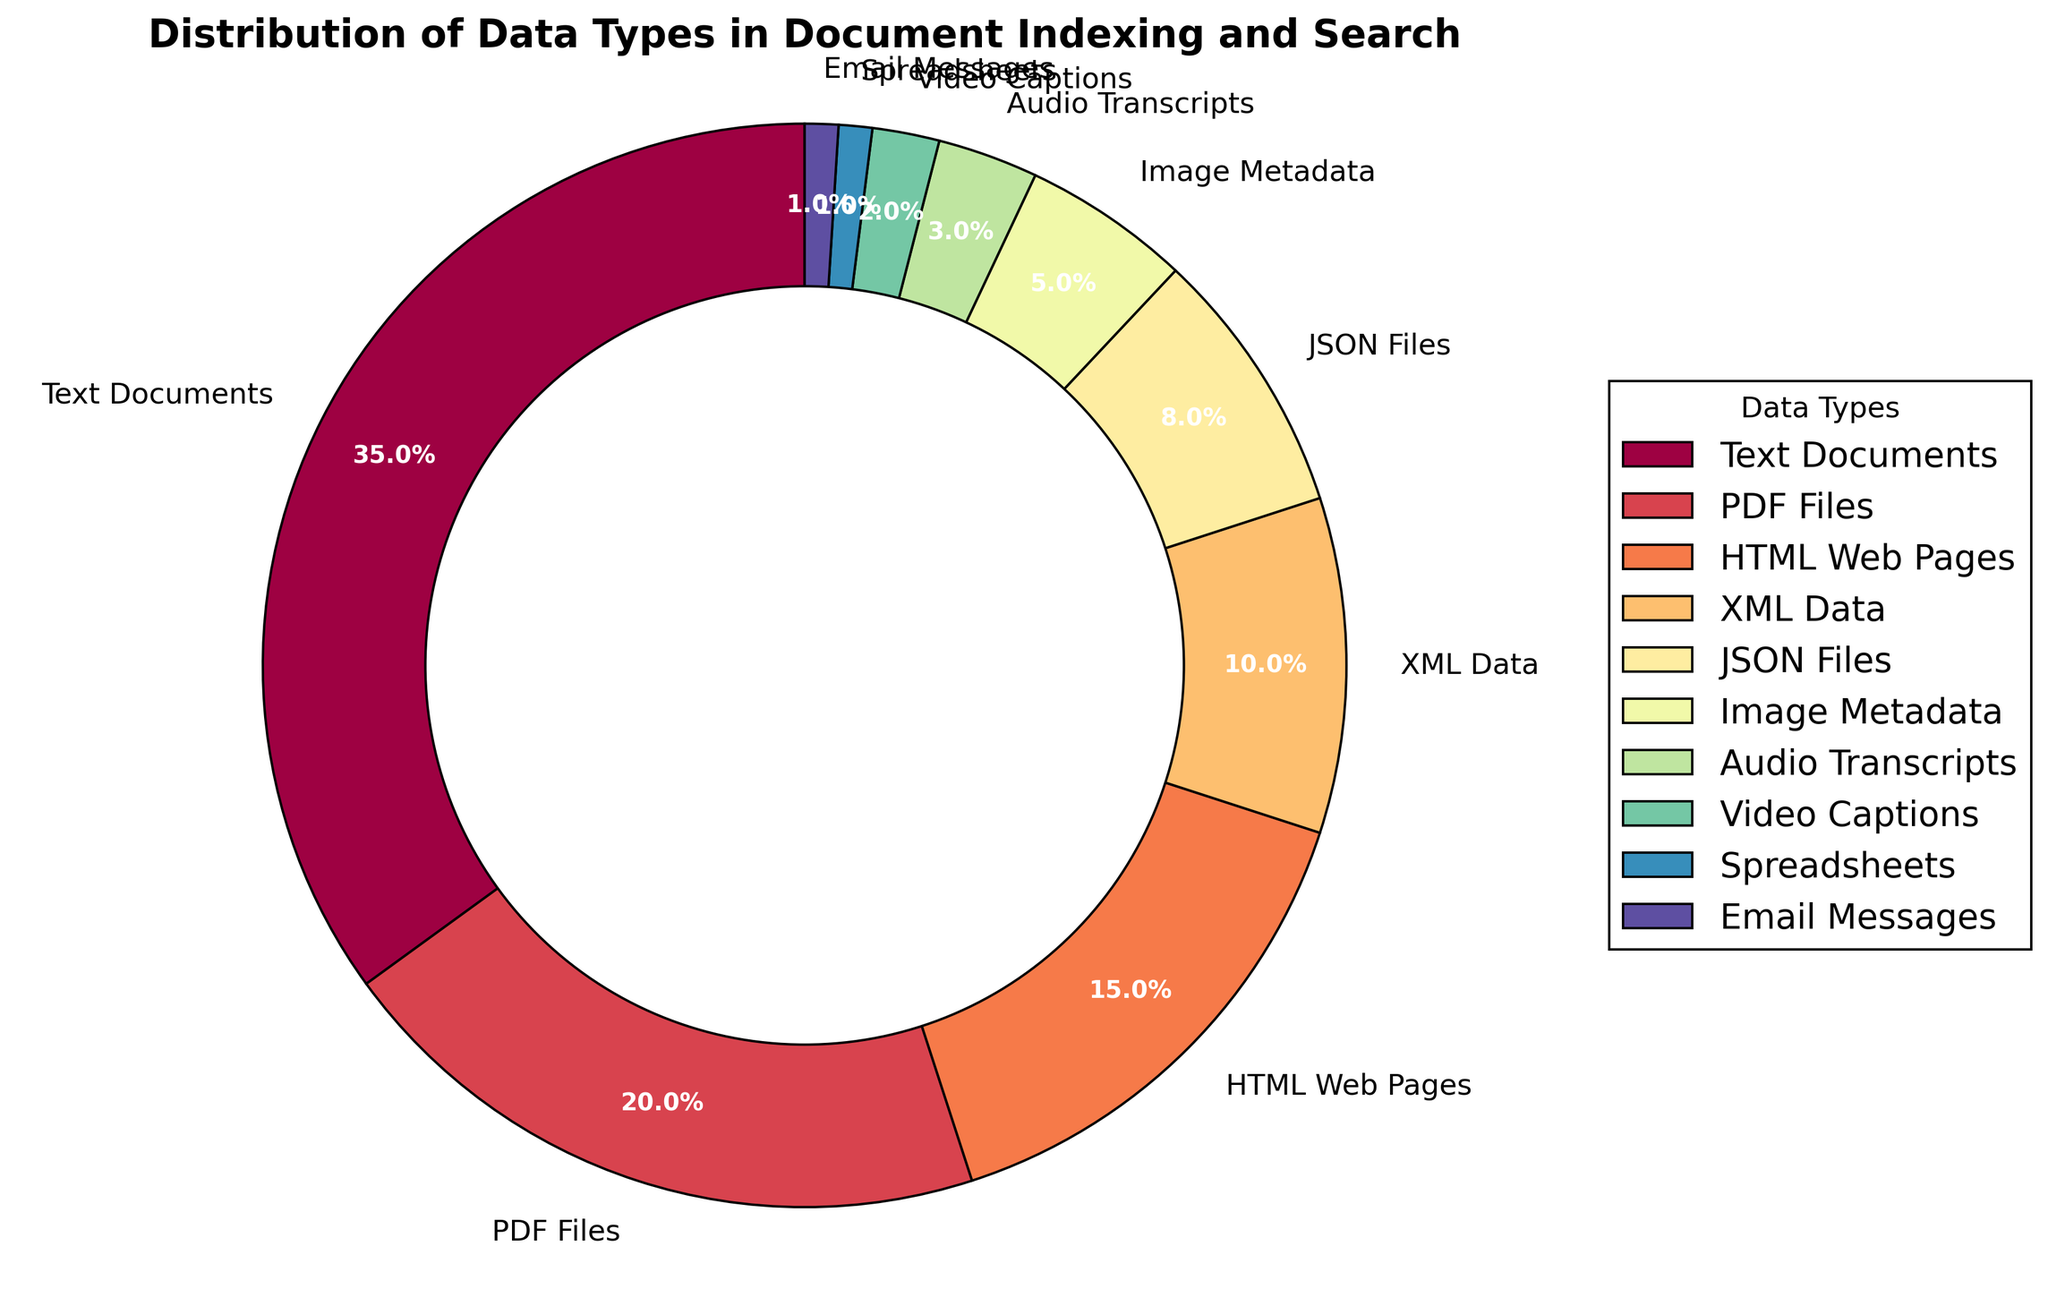What percentage of data types are handled by the algorithm that fall under structured formats like XML and JSON? To find the answer, sum the percentages for XML Data (10%) and JSON Files (8%). The total is 10% + 8% = 18%.
Answer: 18% Which data type has a higher percentage, Text Documents or PDF Files, and by how much? Text Documents account for 35% and PDF Files account for 20%. To find the difference, subtract the percentage of PDF Files from Text Documents: 35% - 20% = 15%.
Answer: Text Documents by 15% What is the combined percentage of data types related to multimedia (Image Metadata, Audio Transcripts, Video Captions)? Sum the percentages for Image Metadata (5%), Audio Transcripts (3%), and Video Captions (2%). The total is 5% + 3% + 2% = 10%.
Answer: 10% What data type is represented by the smallest wedge in the chart? The smallest wedge corresponds to Spreadsheets and Email Messages, each with 1%.
Answer: Spreadsheets and Email Messages Which data type has the third-largest percentage? The third-largest percentage is held by HTML Web Pages, which accounts for 15% of the distribution.
Answer: HTML Web Pages What is the percentage difference between the data types with the largest and smallest distribution? Text Documents have the largest percentage at 35%, while Spreadsheets and Email Messages each have 1%. The difference is 35% - 1% = 34%.
Answer: 34% What is the total percentage for data types under 10%? Sum the percentages for XML Data (10%), JSON Files (8%), Image Metadata (5%), Audio Transcripts (3%), Video Captions (2%), Spreadsheets (1%), and Email Messages (1%). The total is 10% + 8% + 5% + 3% + 2% + 1% + 1% = 30%.
Answer: 30% If you combine Text Documents and HTML Web Pages, what percentage do they represent in total? Sum the percentages for Text Documents (35%) and HTML Web Pages (15%). The total is 35% + 15% = 50%.
Answer: 50% Which section of the pie chart has a reddish color, and what data type does it represent? The reddish wedge represents XML Data, which accounts for 10%.
Answer: XML Data 